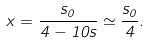Convert formula to latex. <formula><loc_0><loc_0><loc_500><loc_500>x = \frac { s _ { 0 } } { 4 - 1 0 s } \simeq \frac { s _ { 0 } } { 4 } .</formula> 